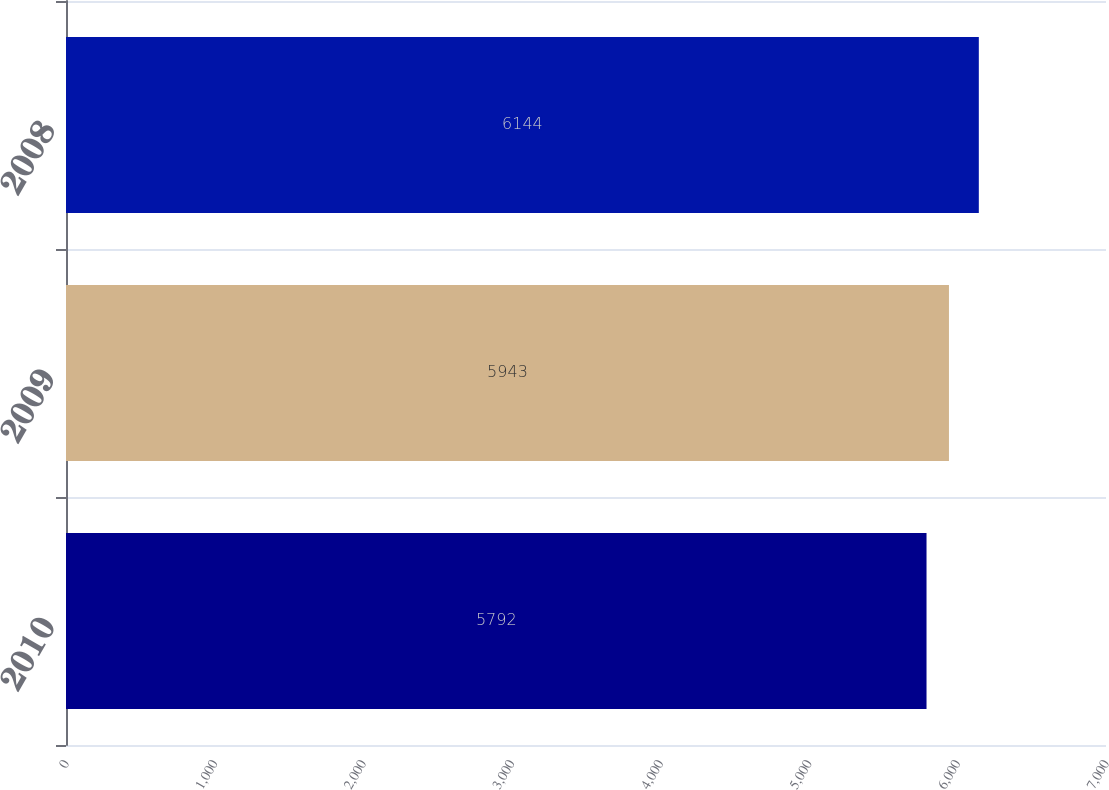Convert chart. <chart><loc_0><loc_0><loc_500><loc_500><bar_chart><fcel>2010<fcel>2009<fcel>2008<nl><fcel>5792<fcel>5943<fcel>6144<nl></chart> 